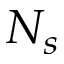Convert formula to latex. <formula><loc_0><loc_0><loc_500><loc_500>N _ { s }</formula> 